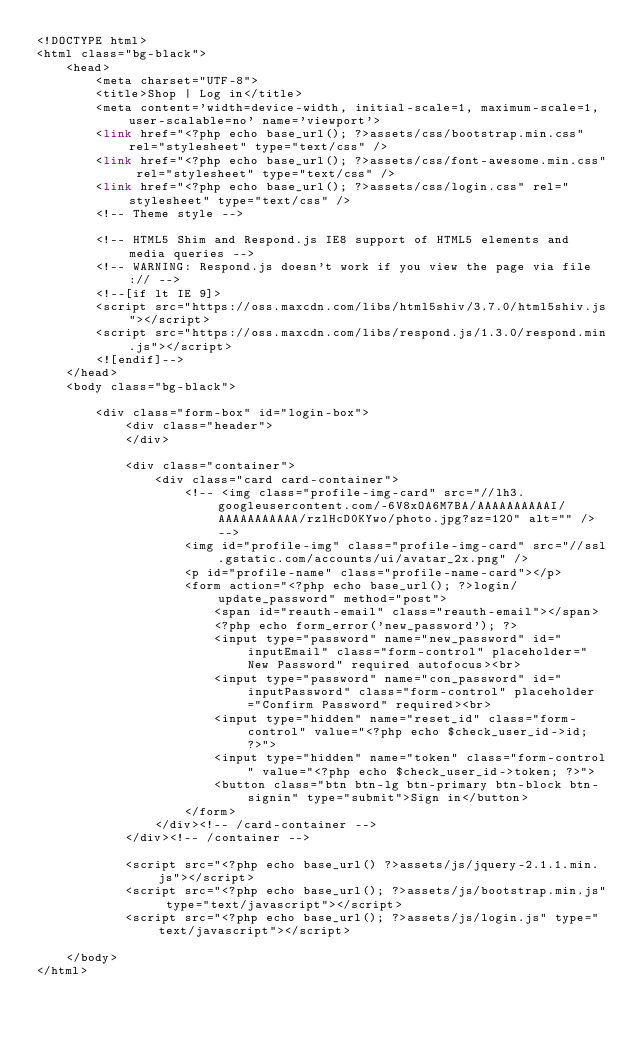Convert code to text. <code><loc_0><loc_0><loc_500><loc_500><_PHP_><!DOCTYPE html>
<html class="bg-black">
    <head>
        <meta charset="UTF-8">
        <title>Shop | Log in</title>
        <meta content='width=device-width, initial-scale=1, maximum-scale=1, user-scalable=no' name='viewport'>
        <link href="<?php echo base_url(); ?>assets/css/bootstrap.min.css" rel="stylesheet" type="text/css" />
        <link href="<?php echo base_url(); ?>assets/css/font-awesome.min.css" rel="stylesheet" type="text/css" />
        <link href="<?php echo base_url(); ?>assets/css/login.css" rel="stylesheet" type="text/css" />
        <!-- Theme style -->

        <!-- HTML5 Shim and Respond.js IE8 support of HTML5 elements and media queries -->
        <!-- WARNING: Respond.js doesn't work if you view the page via file:// -->
        <!--[if lt IE 9]>
        <script src="https://oss.maxcdn.com/libs/html5shiv/3.7.0/html5shiv.js"></script>
        <script src="https://oss.maxcdn.com/libs/respond.js/1.3.0/respond.min.js"></script>
        <![endif]-->
    </head>
    <body class="bg-black">

        <div class="form-box" id="login-box">
            <div class="header">
            </div>

            <div class="container">
                <div class="card card-container">
                    <!-- <img class="profile-img-card" src="//lh3.googleusercontent.com/-6V8xOA6M7BA/AAAAAAAAAAI/AAAAAAAAAAA/rzlHcD0KYwo/photo.jpg?sz=120" alt="" /> -->
                    <img id="profile-img" class="profile-img-card" src="//ssl.gstatic.com/accounts/ui/avatar_2x.png" />
                    <p id="profile-name" class="profile-name-card"></p>
                    <form action="<?php echo base_url(); ?>login/update_password" method="post">
                        <span id="reauth-email" class="reauth-email"></span>
                        <?php echo form_error('new_password'); ?>
                        <input type="password" name="new_password" id="inputEmail" class="form-control" placeholder="New Password" required autofocus><br>
                        <input type="password" name="con_password" id="inputPassword" class="form-control" placeholder="Confirm Password" required><br>
                        <input type="hidden" name="reset_id" class="form-control" value="<?php echo $check_user_id->id; ?>">
                        <input type="hidden" name="token" class="form-control" value="<?php echo $check_user_id->token; ?>">
                        <button class="btn btn-lg btn-primary btn-block btn-signin" type="submit">Sign in</button>
                    </form>
                </div><!-- /card-container -->
            </div><!-- /container -->

            <script src="<?php echo base_url() ?>assets/js/jquery-2.1.1.min.js"></script>
            <script src="<?php echo base_url(); ?>assets/js/bootstrap.min.js" type="text/javascript"></script>
            <script src="<?php echo base_url(); ?>assets/js/login.js" type="text/javascript"></script>

    </body>
</html>
</code> 